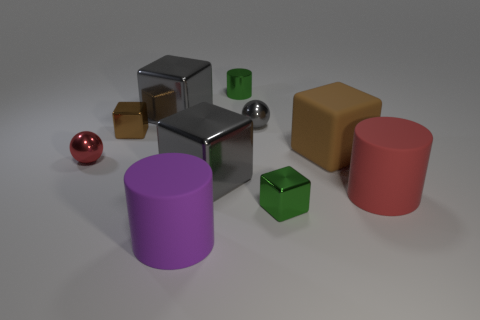There is a rubber object that is in front of the red sphere and on the right side of the small green metallic cube; how big is it?
Your response must be concise. Large. There is a big gray object behind the tiny brown shiny object; does it have the same shape as the tiny green metallic thing in front of the brown matte cube?
Offer a terse response. Yes. There is a small object that is the same color as the matte block; what is its shape?
Offer a terse response. Cube. How many other objects have the same material as the purple thing?
Offer a terse response. 2. What is the shape of the tiny metal thing that is both in front of the tiny brown metallic cube and on the left side of the big purple rubber cylinder?
Provide a succinct answer. Sphere. Does the small block behind the large brown object have the same material as the big purple cylinder?
Provide a succinct answer. No. The rubber block that is the same size as the purple object is what color?
Your answer should be compact. Brown. Is there a metal block that has the same color as the matte block?
Provide a succinct answer. Yes. What is the size of the brown thing that is the same material as the small red sphere?
Your answer should be very brief. Small. The shiny block that is the same color as the large rubber cube is what size?
Offer a very short reply. Small. 